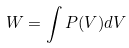Convert formula to latex. <formula><loc_0><loc_0><loc_500><loc_500>W = \int P ( V ) d V</formula> 